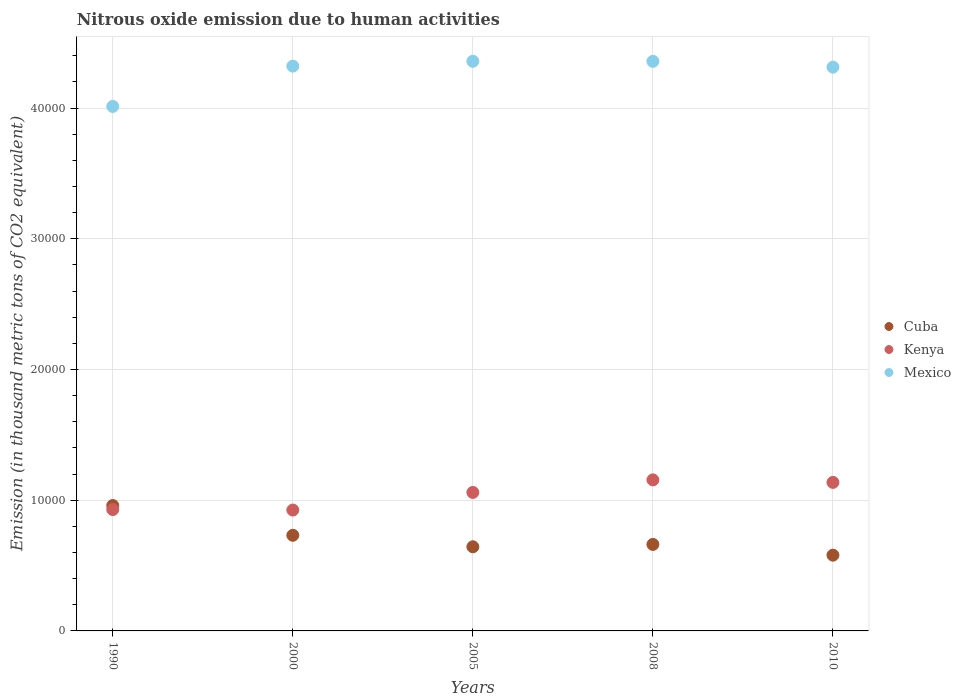How many different coloured dotlines are there?
Give a very brief answer. 3. What is the amount of nitrous oxide emitted in Kenya in 2005?
Your answer should be very brief. 1.06e+04. Across all years, what is the maximum amount of nitrous oxide emitted in Kenya?
Make the answer very short. 1.16e+04. Across all years, what is the minimum amount of nitrous oxide emitted in Kenya?
Give a very brief answer. 9247.6. In which year was the amount of nitrous oxide emitted in Cuba maximum?
Offer a terse response. 1990. What is the total amount of nitrous oxide emitted in Mexico in the graph?
Provide a short and direct response. 2.14e+05. What is the difference between the amount of nitrous oxide emitted in Mexico in 1990 and that in 2000?
Offer a terse response. -3080.7. What is the difference between the amount of nitrous oxide emitted in Cuba in 1990 and the amount of nitrous oxide emitted in Mexico in 2010?
Provide a short and direct response. -3.35e+04. What is the average amount of nitrous oxide emitted in Kenya per year?
Provide a succinct answer. 1.04e+04. In the year 1990, what is the difference between the amount of nitrous oxide emitted in Kenya and amount of nitrous oxide emitted in Cuba?
Offer a terse response. -307.2. In how many years, is the amount of nitrous oxide emitted in Kenya greater than 34000 thousand metric tons?
Offer a terse response. 0. What is the ratio of the amount of nitrous oxide emitted in Kenya in 1990 to that in 2000?
Offer a very short reply. 1. What is the difference between the highest and the second highest amount of nitrous oxide emitted in Kenya?
Your answer should be very brief. 192.1. What is the difference between the highest and the lowest amount of nitrous oxide emitted in Kenya?
Provide a succinct answer. 2308.7. Is it the case that in every year, the sum of the amount of nitrous oxide emitted in Cuba and amount of nitrous oxide emitted in Mexico  is greater than the amount of nitrous oxide emitted in Kenya?
Your response must be concise. Yes. Does the amount of nitrous oxide emitted in Mexico monotonically increase over the years?
Give a very brief answer. No. Is the amount of nitrous oxide emitted in Cuba strictly greater than the amount of nitrous oxide emitted in Mexico over the years?
Ensure brevity in your answer.  No. Is the amount of nitrous oxide emitted in Cuba strictly less than the amount of nitrous oxide emitted in Kenya over the years?
Offer a very short reply. No. How many years are there in the graph?
Your answer should be very brief. 5. What is the difference between two consecutive major ticks on the Y-axis?
Your response must be concise. 10000. Are the values on the major ticks of Y-axis written in scientific E-notation?
Offer a terse response. No. Does the graph contain any zero values?
Offer a very short reply. No. Does the graph contain grids?
Your answer should be compact. Yes. What is the title of the graph?
Make the answer very short. Nitrous oxide emission due to human activities. Does "Other small states" appear as one of the legend labels in the graph?
Provide a succinct answer. No. What is the label or title of the X-axis?
Provide a succinct answer. Years. What is the label or title of the Y-axis?
Keep it short and to the point. Emission (in thousand metric tons of CO2 equivalent). What is the Emission (in thousand metric tons of CO2 equivalent) in Cuba in 1990?
Provide a succinct answer. 9592.9. What is the Emission (in thousand metric tons of CO2 equivalent) in Kenya in 1990?
Your response must be concise. 9285.7. What is the Emission (in thousand metric tons of CO2 equivalent) in Mexico in 1990?
Provide a short and direct response. 4.01e+04. What is the Emission (in thousand metric tons of CO2 equivalent) of Cuba in 2000?
Give a very brief answer. 7317. What is the Emission (in thousand metric tons of CO2 equivalent) of Kenya in 2000?
Give a very brief answer. 9247.6. What is the Emission (in thousand metric tons of CO2 equivalent) of Mexico in 2000?
Ensure brevity in your answer.  4.32e+04. What is the Emission (in thousand metric tons of CO2 equivalent) of Cuba in 2005?
Offer a very short reply. 6437.8. What is the Emission (in thousand metric tons of CO2 equivalent) of Kenya in 2005?
Offer a terse response. 1.06e+04. What is the Emission (in thousand metric tons of CO2 equivalent) in Mexico in 2005?
Your answer should be compact. 4.36e+04. What is the Emission (in thousand metric tons of CO2 equivalent) of Cuba in 2008?
Offer a terse response. 6617.5. What is the Emission (in thousand metric tons of CO2 equivalent) of Kenya in 2008?
Provide a short and direct response. 1.16e+04. What is the Emission (in thousand metric tons of CO2 equivalent) in Mexico in 2008?
Provide a short and direct response. 4.36e+04. What is the Emission (in thousand metric tons of CO2 equivalent) in Cuba in 2010?
Keep it short and to the point. 5796.2. What is the Emission (in thousand metric tons of CO2 equivalent) in Kenya in 2010?
Your response must be concise. 1.14e+04. What is the Emission (in thousand metric tons of CO2 equivalent) of Mexico in 2010?
Offer a terse response. 4.31e+04. Across all years, what is the maximum Emission (in thousand metric tons of CO2 equivalent) in Cuba?
Provide a succinct answer. 9592.9. Across all years, what is the maximum Emission (in thousand metric tons of CO2 equivalent) of Kenya?
Ensure brevity in your answer.  1.16e+04. Across all years, what is the maximum Emission (in thousand metric tons of CO2 equivalent) of Mexico?
Make the answer very short. 4.36e+04. Across all years, what is the minimum Emission (in thousand metric tons of CO2 equivalent) of Cuba?
Provide a succinct answer. 5796.2. Across all years, what is the minimum Emission (in thousand metric tons of CO2 equivalent) in Kenya?
Your answer should be very brief. 9247.6. Across all years, what is the minimum Emission (in thousand metric tons of CO2 equivalent) of Mexico?
Offer a very short reply. 4.01e+04. What is the total Emission (in thousand metric tons of CO2 equivalent) of Cuba in the graph?
Ensure brevity in your answer.  3.58e+04. What is the total Emission (in thousand metric tons of CO2 equivalent) in Kenya in the graph?
Make the answer very short. 5.21e+04. What is the total Emission (in thousand metric tons of CO2 equivalent) of Mexico in the graph?
Your answer should be compact. 2.14e+05. What is the difference between the Emission (in thousand metric tons of CO2 equivalent) in Cuba in 1990 and that in 2000?
Your response must be concise. 2275.9. What is the difference between the Emission (in thousand metric tons of CO2 equivalent) of Kenya in 1990 and that in 2000?
Your answer should be compact. 38.1. What is the difference between the Emission (in thousand metric tons of CO2 equivalent) of Mexico in 1990 and that in 2000?
Make the answer very short. -3080.7. What is the difference between the Emission (in thousand metric tons of CO2 equivalent) of Cuba in 1990 and that in 2005?
Your answer should be compact. 3155.1. What is the difference between the Emission (in thousand metric tons of CO2 equivalent) in Kenya in 1990 and that in 2005?
Offer a very short reply. -1310.7. What is the difference between the Emission (in thousand metric tons of CO2 equivalent) of Mexico in 1990 and that in 2005?
Give a very brief answer. -3453. What is the difference between the Emission (in thousand metric tons of CO2 equivalent) in Cuba in 1990 and that in 2008?
Give a very brief answer. 2975.4. What is the difference between the Emission (in thousand metric tons of CO2 equivalent) of Kenya in 1990 and that in 2008?
Offer a terse response. -2270.6. What is the difference between the Emission (in thousand metric tons of CO2 equivalent) of Mexico in 1990 and that in 2008?
Offer a very short reply. -3446.9. What is the difference between the Emission (in thousand metric tons of CO2 equivalent) of Cuba in 1990 and that in 2010?
Your answer should be very brief. 3796.7. What is the difference between the Emission (in thousand metric tons of CO2 equivalent) in Kenya in 1990 and that in 2010?
Offer a terse response. -2078.5. What is the difference between the Emission (in thousand metric tons of CO2 equivalent) of Mexico in 1990 and that in 2010?
Give a very brief answer. -3004.3. What is the difference between the Emission (in thousand metric tons of CO2 equivalent) in Cuba in 2000 and that in 2005?
Keep it short and to the point. 879.2. What is the difference between the Emission (in thousand metric tons of CO2 equivalent) of Kenya in 2000 and that in 2005?
Ensure brevity in your answer.  -1348.8. What is the difference between the Emission (in thousand metric tons of CO2 equivalent) in Mexico in 2000 and that in 2005?
Give a very brief answer. -372.3. What is the difference between the Emission (in thousand metric tons of CO2 equivalent) in Cuba in 2000 and that in 2008?
Provide a succinct answer. 699.5. What is the difference between the Emission (in thousand metric tons of CO2 equivalent) in Kenya in 2000 and that in 2008?
Offer a very short reply. -2308.7. What is the difference between the Emission (in thousand metric tons of CO2 equivalent) of Mexico in 2000 and that in 2008?
Ensure brevity in your answer.  -366.2. What is the difference between the Emission (in thousand metric tons of CO2 equivalent) in Cuba in 2000 and that in 2010?
Provide a short and direct response. 1520.8. What is the difference between the Emission (in thousand metric tons of CO2 equivalent) of Kenya in 2000 and that in 2010?
Your answer should be very brief. -2116.6. What is the difference between the Emission (in thousand metric tons of CO2 equivalent) in Mexico in 2000 and that in 2010?
Your response must be concise. 76.4. What is the difference between the Emission (in thousand metric tons of CO2 equivalent) of Cuba in 2005 and that in 2008?
Give a very brief answer. -179.7. What is the difference between the Emission (in thousand metric tons of CO2 equivalent) in Kenya in 2005 and that in 2008?
Keep it short and to the point. -959.9. What is the difference between the Emission (in thousand metric tons of CO2 equivalent) of Mexico in 2005 and that in 2008?
Provide a short and direct response. 6.1. What is the difference between the Emission (in thousand metric tons of CO2 equivalent) in Cuba in 2005 and that in 2010?
Provide a short and direct response. 641.6. What is the difference between the Emission (in thousand metric tons of CO2 equivalent) of Kenya in 2005 and that in 2010?
Give a very brief answer. -767.8. What is the difference between the Emission (in thousand metric tons of CO2 equivalent) of Mexico in 2005 and that in 2010?
Provide a short and direct response. 448.7. What is the difference between the Emission (in thousand metric tons of CO2 equivalent) of Cuba in 2008 and that in 2010?
Provide a short and direct response. 821.3. What is the difference between the Emission (in thousand metric tons of CO2 equivalent) in Kenya in 2008 and that in 2010?
Make the answer very short. 192.1. What is the difference between the Emission (in thousand metric tons of CO2 equivalent) of Mexico in 2008 and that in 2010?
Your answer should be compact. 442.6. What is the difference between the Emission (in thousand metric tons of CO2 equivalent) of Cuba in 1990 and the Emission (in thousand metric tons of CO2 equivalent) of Kenya in 2000?
Offer a terse response. 345.3. What is the difference between the Emission (in thousand metric tons of CO2 equivalent) in Cuba in 1990 and the Emission (in thousand metric tons of CO2 equivalent) in Mexico in 2000?
Your answer should be very brief. -3.36e+04. What is the difference between the Emission (in thousand metric tons of CO2 equivalent) of Kenya in 1990 and the Emission (in thousand metric tons of CO2 equivalent) of Mexico in 2000?
Your answer should be compact. -3.39e+04. What is the difference between the Emission (in thousand metric tons of CO2 equivalent) of Cuba in 1990 and the Emission (in thousand metric tons of CO2 equivalent) of Kenya in 2005?
Your answer should be compact. -1003.5. What is the difference between the Emission (in thousand metric tons of CO2 equivalent) of Cuba in 1990 and the Emission (in thousand metric tons of CO2 equivalent) of Mexico in 2005?
Provide a short and direct response. -3.40e+04. What is the difference between the Emission (in thousand metric tons of CO2 equivalent) in Kenya in 1990 and the Emission (in thousand metric tons of CO2 equivalent) in Mexico in 2005?
Provide a short and direct response. -3.43e+04. What is the difference between the Emission (in thousand metric tons of CO2 equivalent) in Cuba in 1990 and the Emission (in thousand metric tons of CO2 equivalent) in Kenya in 2008?
Give a very brief answer. -1963.4. What is the difference between the Emission (in thousand metric tons of CO2 equivalent) of Cuba in 1990 and the Emission (in thousand metric tons of CO2 equivalent) of Mexico in 2008?
Give a very brief answer. -3.40e+04. What is the difference between the Emission (in thousand metric tons of CO2 equivalent) of Kenya in 1990 and the Emission (in thousand metric tons of CO2 equivalent) of Mexico in 2008?
Keep it short and to the point. -3.43e+04. What is the difference between the Emission (in thousand metric tons of CO2 equivalent) in Cuba in 1990 and the Emission (in thousand metric tons of CO2 equivalent) in Kenya in 2010?
Offer a terse response. -1771.3. What is the difference between the Emission (in thousand metric tons of CO2 equivalent) in Cuba in 1990 and the Emission (in thousand metric tons of CO2 equivalent) in Mexico in 2010?
Make the answer very short. -3.35e+04. What is the difference between the Emission (in thousand metric tons of CO2 equivalent) in Kenya in 1990 and the Emission (in thousand metric tons of CO2 equivalent) in Mexico in 2010?
Offer a terse response. -3.38e+04. What is the difference between the Emission (in thousand metric tons of CO2 equivalent) of Cuba in 2000 and the Emission (in thousand metric tons of CO2 equivalent) of Kenya in 2005?
Your response must be concise. -3279.4. What is the difference between the Emission (in thousand metric tons of CO2 equivalent) in Cuba in 2000 and the Emission (in thousand metric tons of CO2 equivalent) in Mexico in 2005?
Your answer should be compact. -3.63e+04. What is the difference between the Emission (in thousand metric tons of CO2 equivalent) of Kenya in 2000 and the Emission (in thousand metric tons of CO2 equivalent) of Mexico in 2005?
Your answer should be very brief. -3.43e+04. What is the difference between the Emission (in thousand metric tons of CO2 equivalent) of Cuba in 2000 and the Emission (in thousand metric tons of CO2 equivalent) of Kenya in 2008?
Provide a succinct answer. -4239.3. What is the difference between the Emission (in thousand metric tons of CO2 equivalent) of Cuba in 2000 and the Emission (in thousand metric tons of CO2 equivalent) of Mexico in 2008?
Give a very brief answer. -3.63e+04. What is the difference between the Emission (in thousand metric tons of CO2 equivalent) of Kenya in 2000 and the Emission (in thousand metric tons of CO2 equivalent) of Mexico in 2008?
Offer a terse response. -3.43e+04. What is the difference between the Emission (in thousand metric tons of CO2 equivalent) in Cuba in 2000 and the Emission (in thousand metric tons of CO2 equivalent) in Kenya in 2010?
Provide a short and direct response. -4047.2. What is the difference between the Emission (in thousand metric tons of CO2 equivalent) of Cuba in 2000 and the Emission (in thousand metric tons of CO2 equivalent) of Mexico in 2010?
Provide a succinct answer. -3.58e+04. What is the difference between the Emission (in thousand metric tons of CO2 equivalent) of Kenya in 2000 and the Emission (in thousand metric tons of CO2 equivalent) of Mexico in 2010?
Provide a short and direct response. -3.39e+04. What is the difference between the Emission (in thousand metric tons of CO2 equivalent) of Cuba in 2005 and the Emission (in thousand metric tons of CO2 equivalent) of Kenya in 2008?
Offer a terse response. -5118.5. What is the difference between the Emission (in thousand metric tons of CO2 equivalent) of Cuba in 2005 and the Emission (in thousand metric tons of CO2 equivalent) of Mexico in 2008?
Give a very brief answer. -3.71e+04. What is the difference between the Emission (in thousand metric tons of CO2 equivalent) in Kenya in 2005 and the Emission (in thousand metric tons of CO2 equivalent) in Mexico in 2008?
Your answer should be compact. -3.30e+04. What is the difference between the Emission (in thousand metric tons of CO2 equivalent) of Cuba in 2005 and the Emission (in thousand metric tons of CO2 equivalent) of Kenya in 2010?
Offer a terse response. -4926.4. What is the difference between the Emission (in thousand metric tons of CO2 equivalent) in Cuba in 2005 and the Emission (in thousand metric tons of CO2 equivalent) in Mexico in 2010?
Make the answer very short. -3.67e+04. What is the difference between the Emission (in thousand metric tons of CO2 equivalent) of Kenya in 2005 and the Emission (in thousand metric tons of CO2 equivalent) of Mexico in 2010?
Provide a succinct answer. -3.25e+04. What is the difference between the Emission (in thousand metric tons of CO2 equivalent) in Cuba in 2008 and the Emission (in thousand metric tons of CO2 equivalent) in Kenya in 2010?
Keep it short and to the point. -4746.7. What is the difference between the Emission (in thousand metric tons of CO2 equivalent) of Cuba in 2008 and the Emission (in thousand metric tons of CO2 equivalent) of Mexico in 2010?
Your answer should be compact. -3.65e+04. What is the difference between the Emission (in thousand metric tons of CO2 equivalent) in Kenya in 2008 and the Emission (in thousand metric tons of CO2 equivalent) in Mexico in 2010?
Offer a very short reply. -3.16e+04. What is the average Emission (in thousand metric tons of CO2 equivalent) of Cuba per year?
Make the answer very short. 7152.28. What is the average Emission (in thousand metric tons of CO2 equivalent) of Kenya per year?
Offer a terse response. 1.04e+04. What is the average Emission (in thousand metric tons of CO2 equivalent) of Mexico per year?
Make the answer very short. 4.27e+04. In the year 1990, what is the difference between the Emission (in thousand metric tons of CO2 equivalent) of Cuba and Emission (in thousand metric tons of CO2 equivalent) of Kenya?
Ensure brevity in your answer.  307.2. In the year 1990, what is the difference between the Emission (in thousand metric tons of CO2 equivalent) of Cuba and Emission (in thousand metric tons of CO2 equivalent) of Mexico?
Make the answer very short. -3.05e+04. In the year 1990, what is the difference between the Emission (in thousand metric tons of CO2 equivalent) of Kenya and Emission (in thousand metric tons of CO2 equivalent) of Mexico?
Your response must be concise. -3.08e+04. In the year 2000, what is the difference between the Emission (in thousand metric tons of CO2 equivalent) of Cuba and Emission (in thousand metric tons of CO2 equivalent) of Kenya?
Offer a terse response. -1930.6. In the year 2000, what is the difference between the Emission (in thousand metric tons of CO2 equivalent) in Cuba and Emission (in thousand metric tons of CO2 equivalent) in Mexico?
Provide a succinct answer. -3.59e+04. In the year 2000, what is the difference between the Emission (in thousand metric tons of CO2 equivalent) of Kenya and Emission (in thousand metric tons of CO2 equivalent) of Mexico?
Provide a short and direct response. -3.40e+04. In the year 2005, what is the difference between the Emission (in thousand metric tons of CO2 equivalent) of Cuba and Emission (in thousand metric tons of CO2 equivalent) of Kenya?
Offer a very short reply. -4158.6. In the year 2005, what is the difference between the Emission (in thousand metric tons of CO2 equivalent) of Cuba and Emission (in thousand metric tons of CO2 equivalent) of Mexico?
Provide a succinct answer. -3.71e+04. In the year 2005, what is the difference between the Emission (in thousand metric tons of CO2 equivalent) of Kenya and Emission (in thousand metric tons of CO2 equivalent) of Mexico?
Your response must be concise. -3.30e+04. In the year 2008, what is the difference between the Emission (in thousand metric tons of CO2 equivalent) of Cuba and Emission (in thousand metric tons of CO2 equivalent) of Kenya?
Provide a succinct answer. -4938.8. In the year 2008, what is the difference between the Emission (in thousand metric tons of CO2 equivalent) in Cuba and Emission (in thousand metric tons of CO2 equivalent) in Mexico?
Provide a succinct answer. -3.70e+04. In the year 2008, what is the difference between the Emission (in thousand metric tons of CO2 equivalent) in Kenya and Emission (in thousand metric tons of CO2 equivalent) in Mexico?
Ensure brevity in your answer.  -3.20e+04. In the year 2010, what is the difference between the Emission (in thousand metric tons of CO2 equivalent) in Cuba and Emission (in thousand metric tons of CO2 equivalent) in Kenya?
Offer a terse response. -5568. In the year 2010, what is the difference between the Emission (in thousand metric tons of CO2 equivalent) in Cuba and Emission (in thousand metric tons of CO2 equivalent) in Mexico?
Your answer should be compact. -3.73e+04. In the year 2010, what is the difference between the Emission (in thousand metric tons of CO2 equivalent) in Kenya and Emission (in thousand metric tons of CO2 equivalent) in Mexico?
Your answer should be very brief. -3.18e+04. What is the ratio of the Emission (in thousand metric tons of CO2 equivalent) of Cuba in 1990 to that in 2000?
Your response must be concise. 1.31. What is the ratio of the Emission (in thousand metric tons of CO2 equivalent) in Mexico in 1990 to that in 2000?
Offer a very short reply. 0.93. What is the ratio of the Emission (in thousand metric tons of CO2 equivalent) in Cuba in 1990 to that in 2005?
Give a very brief answer. 1.49. What is the ratio of the Emission (in thousand metric tons of CO2 equivalent) of Kenya in 1990 to that in 2005?
Provide a succinct answer. 0.88. What is the ratio of the Emission (in thousand metric tons of CO2 equivalent) of Mexico in 1990 to that in 2005?
Ensure brevity in your answer.  0.92. What is the ratio of the Emission (in thousand metric tons of CO2 equivalent) of Cuba in 1990 to that in 2008?
Your answer should be very brief. 1.45. What is the ratio of the Emission (in thousand metric tons of CO2 equivalent) of Kenya in 1990 to that in 2008?
Give a very brief answer. 0.8. What is the ratio of the Emission (in thousand metric tons of CO2 equivalent) in Mexico in 1990 to that in 2008?
Ensure brevity in your answer.  0.92. What is the ratio of the Emission (in thousand metric tons of CO2 equivalent) of Cuba in 1990 to that in 2010?
Offer a very short reply. 1.66. What is the ratio of the Emission (in thousand metric tons of CO2 equivalent) in Kenya in 1990 to that in 2010?
Provide a succinct answer. 0.82. What is the ratio of the Emission (in thousand metric tons of CO2 equivalent) of Mexico in 1990 to that in 2010?
Provide a succinct answer. 0.93. What is the ratio of the Emission (in thousand metric tons of CO2 equivalent) of Cuba in 2000 to that in 2005?
Your answer should be very brief. 1.14. What is the ratio of the Emission (in thousand metric tons of CO2 equivalent) in Kenya in 2000 to that in 2005?
Provide a succinct answer. 0.87. What is the ratio of the Emission (in thousand metric tons of CO2 equivalent) in Mexico in 2000 to that in 2005?
Offer a terse response. 0.99. What is the ratio of the Emission (in thousand metric tons of CO2 equivalent) of Cuba in 2000 to that in 2008?
Give a very brief answer. 1.11. What is the ratio of the Emission (in thousand metric tons of CO2 equivalent) of Kenya in 2000 to that in 2008?
Give a very brief answer. 0.8. What is the ratio of the Emission (in thousand metric tons of CO2 equivalent) in Cuba in 2000 to that in 2010?
Keep it short and to the point. 1.26. What is the ratio of the Emission (in thousand metric tons of CO2 equivalent) of Kenya in 2000 to that in 2010?
Make the answer very short. 0.81. What is the ratio of the Emission (in thousand metric tons of CO2 equivalent) of Mexico in 2000 to that in 2010?
Provide a succinct answer. 1. What is the ratio of the Emission (in thousand metric tons of CO2 equivalent) of Cuba in 2005 to that in 2008?
Your response must be concise. 0.97. What is the ratio of the Emission (in thousand metric tons of CO2 equivalent) of Kenya in 2005 to that in 2008?
Offer a terse response. 0.92. What is the ratio of the Emission (in thousand metric tons of CO2 equivalent) in Mexico in 2005 to that in 2008?
Give a very brief answer. 1. What is the ratio of the Emission (in thousand metric tons of CO2 equivalent) in Cuba in 2005 to that in 2010?
Your answer should be very brief. 1.11. What is the ratio of the Emission (in thousand metric tons of CO2 equivalent) in Kenya in 2005 to that in 2010?
Provide a succinct answer. 0.93. What is the ratio of the Emission (in thousand metric tons of CO2 equivalent) of Mexico in 2005 to that in 2010?
Offer a very short reply. 1.01. What is the ratio of the Emission (in thousand metric tons of CO2 equivalent) in Cuba in 2008 to that in 2010?
Make the answer very short. 1.14. What is the ratio of the Emission (in thousand metric tons of CO2 equivalent) of Kenya in 2008 to that in 2010?
Offer a terse response. 1.02. What is the ratio of the Emission (in thousand metric tons of CO2 equivalent) of Mexico in 2008 to that in 2010?
Give a very brief answer. 1.01. What is the difference between the highest and the second highest Emission (in thousand metric tons of CO2 equivalent) of Cuba?
Provide a short and direct response. 2275.9. What is the difference between the highest and the second highest Emission (in thousand metric tons of CO2 equivalent) of Kenya?
Make the answer very short. 192.1. What is the difference between the highest and the second highest Emission (in thousand metric tons of CO2 equivalent) of Mexico?
Give a very brief answer. 6.1. What is the difference between the highest and the lowest Emission (in thousand metric tons of CO2 equivalent) in Cuba?
Make the answer very short. 3796.7. What is the difference between the highest and the lowest Emission (in thousand metric tons of CO2 equivalent) in Kenya?
Your response must be concise. 2308.7. What is the difference between the highest and the lowest Emission (in thousand metric tons of CO2 equivalent) of Mexico?
Your answer should be very brief. 3453. 